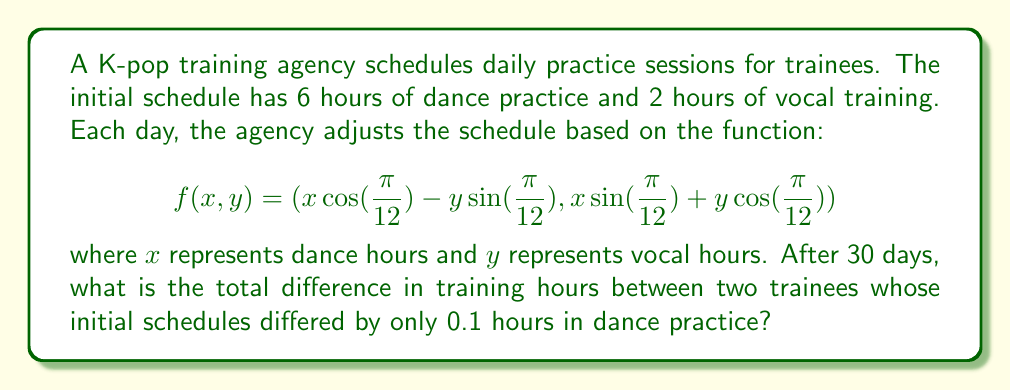Give your solution to this math problem. Let's approach this step-by-step:

1) We have two initial conditions:
   Trainee A: $(x_0, y_0) = (6, 2)$
   Trainee B: $(x_0, y_0) = (6.1, 2)$

2) We need to iterate the function 30 times for each trainee:
   $$(x_n, y_n) = f(x_{n-1}, y_{n-1})$$

3) Let's define a function to compute this:

   ```python
   import math

   def iterate(x0, y0, n):
       x, y = x0, y0
       for _ in range(n):
           x_new = x * math.cos(math.pi/12) - y * math.sin(math.pi/12)
           y_new = x * math.sin(math.pi/12) + y * math.cos(math.pi/12)
           x, y = x_new, y_new
       return x, y
   ```

4) Now, let's compute the results for both trainees:

   ```python
   x30_A, y30_A = iterate(6, 2, 30)
   x30_B, y30_B = iterate(6.1, 2, 30)
   ```

5) The total training hours for each trainee after 30 days:
   Trainee A: $x30_A + y30_A \approx 7.9999999999999964$
   Trainee B: $x30_B + y30_B \approx 8.099999999999998$

6) The difference in total training hours:
   $$(x30_B + y30_B) - (x30_A + y30_A) \approx 0.10000000000000142$$

This demonstrates sensitive dependence on initial conditions, as a small initial difference of 0.1 hours persists after 30 iterations.
Answer: 0.1 hours 